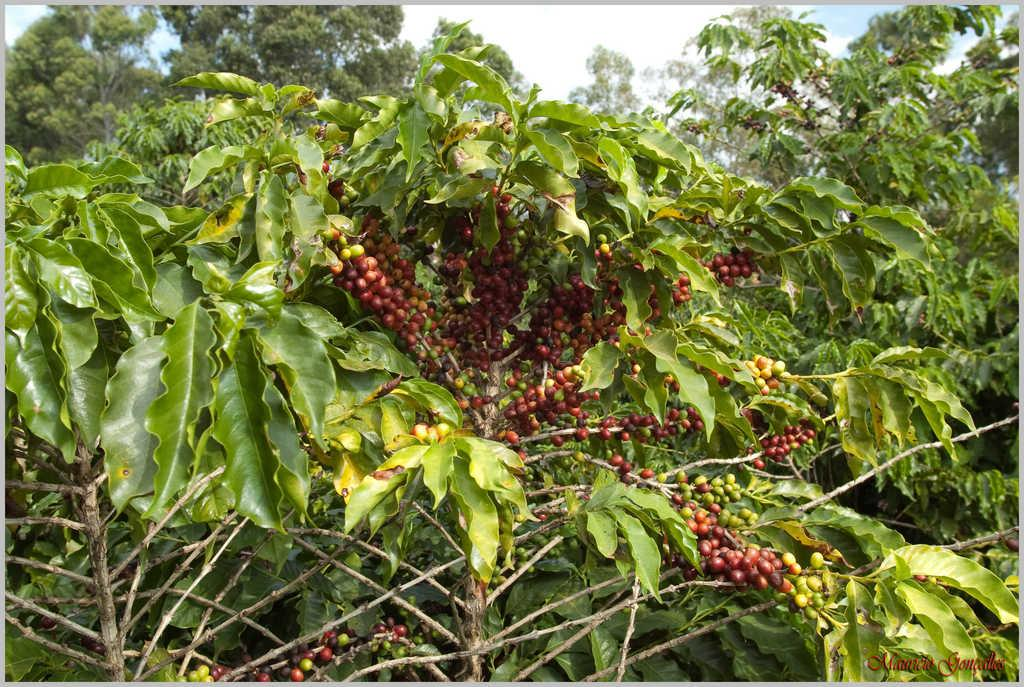What type of trees can be seen in the image? There are fruit trees in the image. What type of wheel can be seen on the fruit trees in the image? There are no wheels present on the fruit trees in the image. What religious beliefs are associated with the fruit trees in the image? There is no information about religious beliefs in the image, as it only shows fruit trees. 